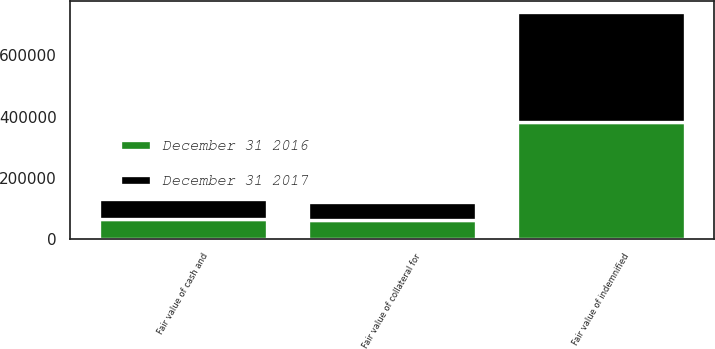Convert chart. <chart><loc_0><loc_0><loc_500><loc_500><stacked_bar_chart><ecel><fcel>Fair value of indemnified<fcel>Fair value of cash and<fcel>Fair value of collateral for<nl><fcel>December 31 2016<fcel>381817<fcel>65272<fcel>61270<nl><fcel>December 31 2017<fcel>360452<fcel>63959<fcel>60003<nl></chart> 